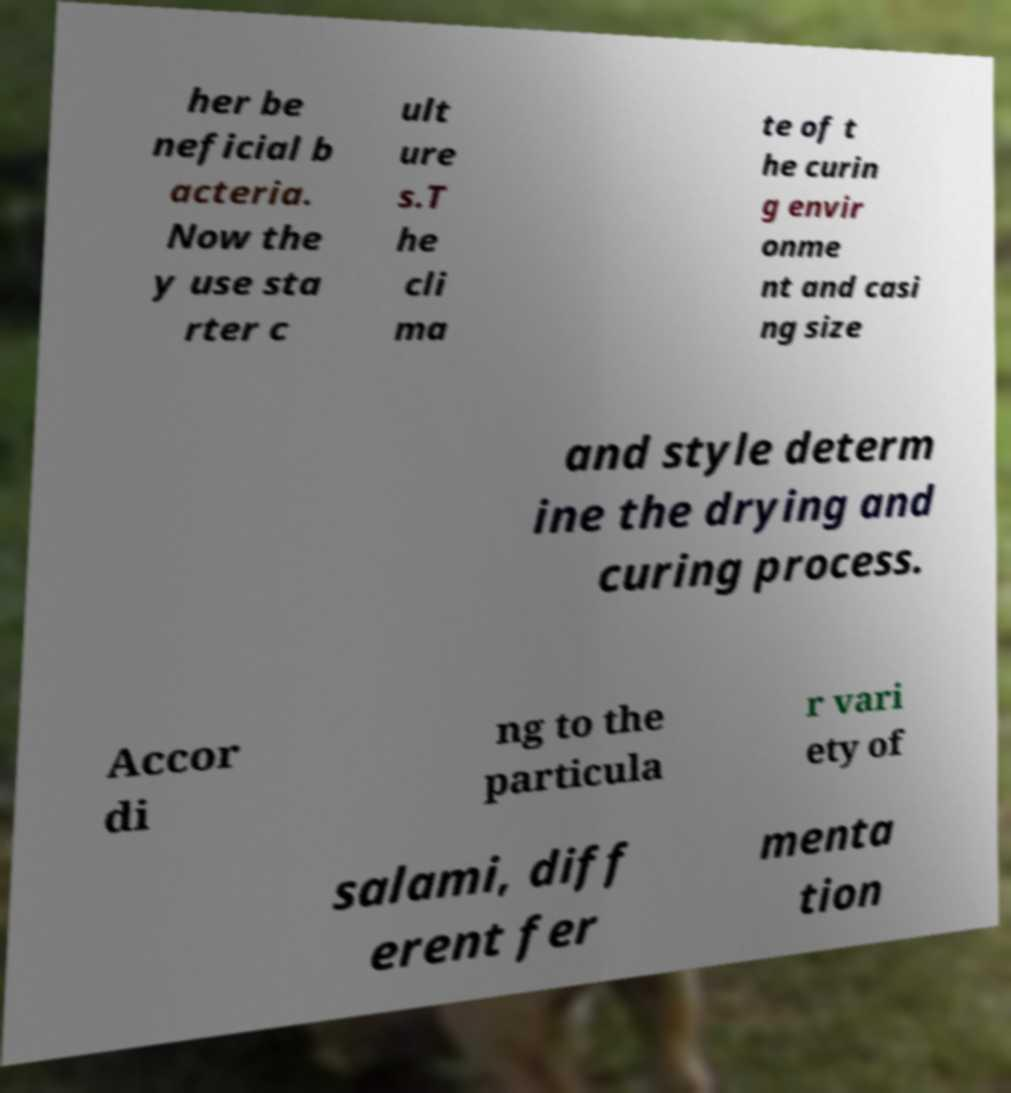Can you read and provide the text displayed in the image?This photo seems to have some interesting text. Can you extract and type it out for me? her be neficial b acteria. Now the y use sta rter c ult ure s.T he cli ma te of t he curin g envir onme nt and casi ng size and style determ ine the drying and curing process. Accor di ng to the particula r vari ety of salami, diff erent fer menta tion 